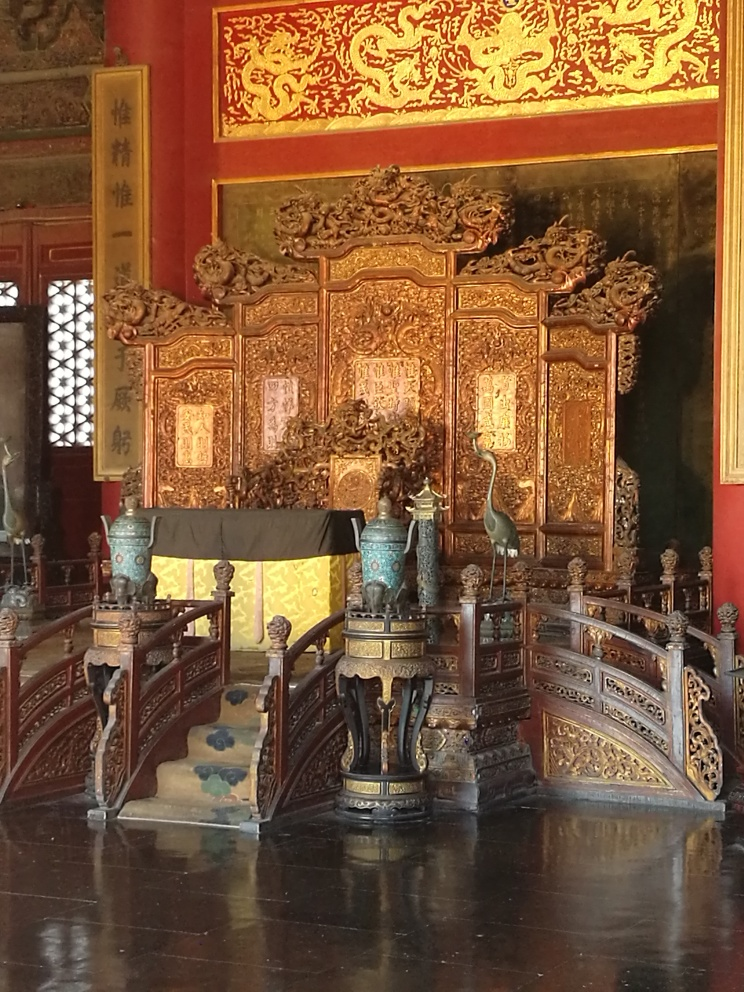Can you tell me what era or culture this throne might represent? The throne appears to reflect East Asian design, potentially Chinese. The use of red and gold, the dragon motifs, and calligraphy suggest it could be from the Qing dynasty, known for its opulent artistic expressions in royal settings. What do the symbols and artwork signify? The dragons are emblematic of power and strength in Chinese culture and often represent the emperor. The calligraphy could be poems or phrases bestowing blessings or conveying the status of the emperor. The intricate patterns and richness of materials underscore the throne's ceremonial importance and the ruler's supreme status. 